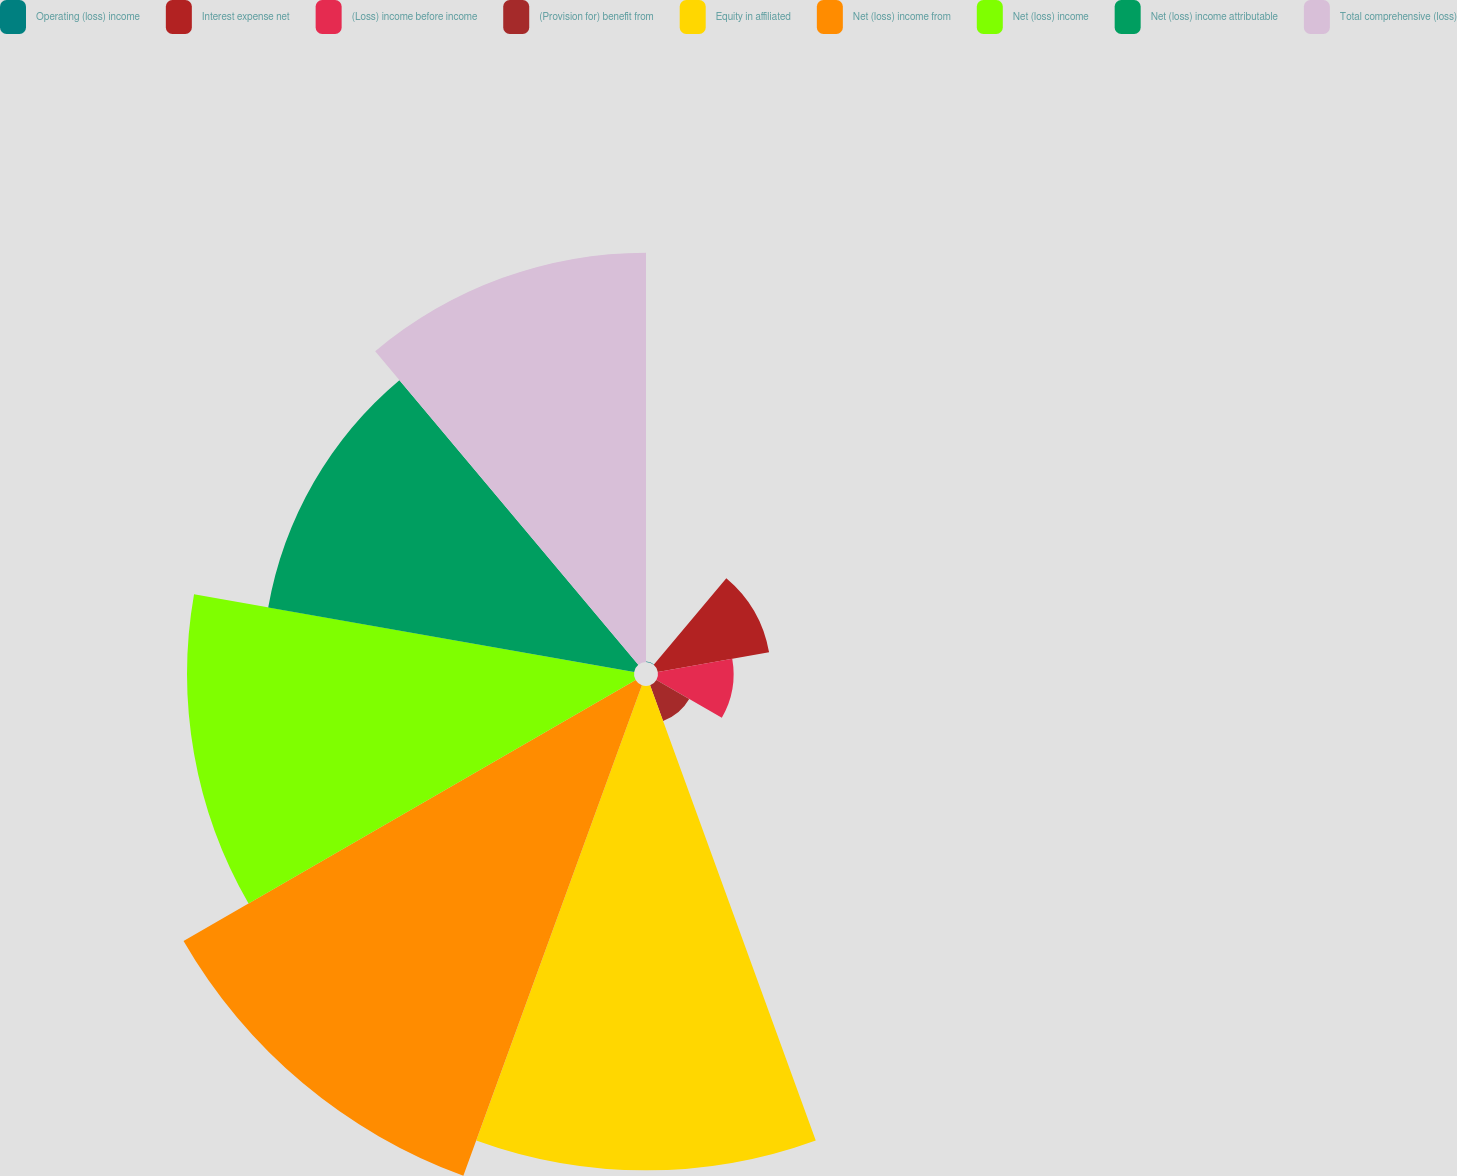<chart> <loc_0><loc_0><loc_500><loc_500><pie_chart><fcel>Operating (loss) income<fcel>Interest expense net<fcel>(Loss) income before income<fcel>(Provision for) benefit from<fcel>Equity in affiliated<fcel>Net (loss) income from<fcel>Net (loss) income<fcel>Net (loss) income attributable<fcel>Total comprehensive (loss)<nl><fcel>0.02%<fcel>4.59%<fcel>3.07%<fcel>1.54%<fcel>19.68%<fcel>21.21%<fcel>18.16%<fcel>15.1%<fcel>16.63%<nl></chart> 